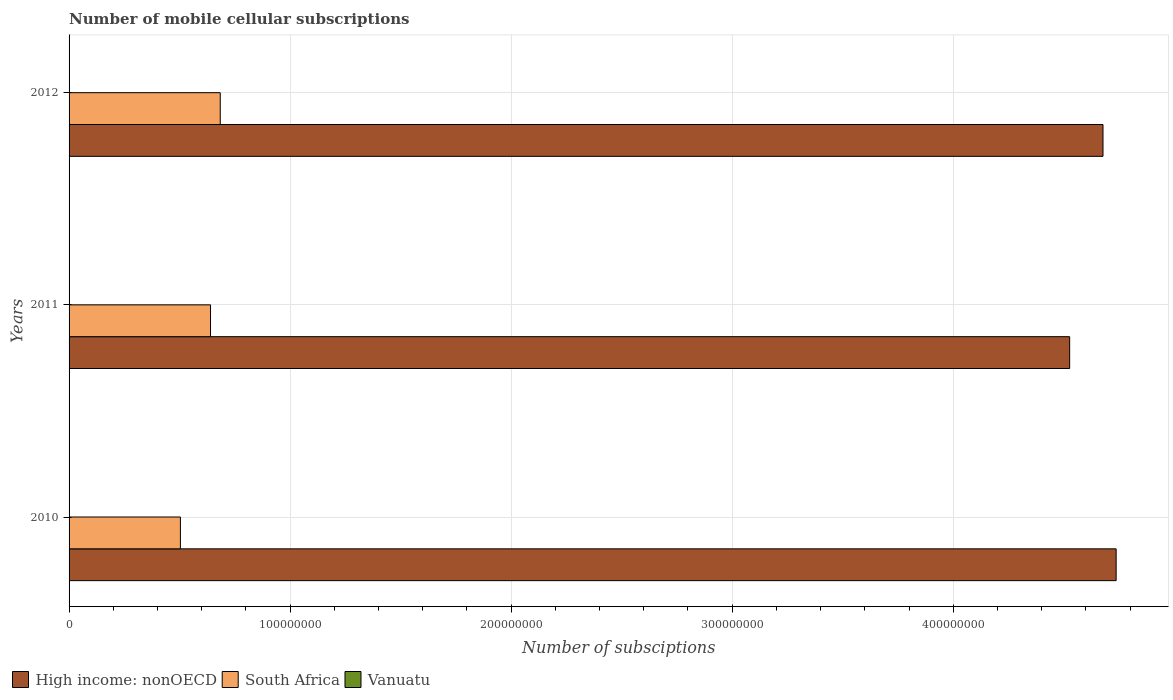How many different coloured bars are there?
Your answer should be very brief. 3. Are the number of bars per tick equal to the number of legend labels?
Ensure brevity in your answer.  Yes. How many bars are there on the 1st tick from the top?
Make the answer very short. 3. How many bars are there on the 1st tick from the bottom?
Your response must be concise. 3. What is the label of the 1st group of bars from the top?
Your response must be concise. 2012. In how many cases, is the number of bars for a given year not equal to the number of legend labels?
Offer a very short reply. 0. What is the number of mobile cellular subscriptions in Vanuatu in 2012?
Provide a short and direct response. 1.46e+05. Across all years, what is the maximum number of mobile cellular subscriptions in Vanuatu?
Make the answer very short. 1.70e+05. Across all years, what is the minimum number of mobile cellular subscriptions in South Africa?
Provide a short and direct response. 5.04e+07. What is the total number of mobile cellular subscriptions in South Africa in the graph?
Keep it short and to the point. 1.83e+08. What is the difference between the number of mobile cellular subscriptions in South Africa in 2010 and that in 2011?
Provide a succinct answer. -1.36e+07. What is the difference between the number of mobile cellular subscriptions in South Africa in 2010 and the number of mobile cellular subscriptions in High income: nonOECD in 2012?
Ensure brevity in your answer.  -4.17e+08. What is the average number of mobile cellular subscriptions in Vanuatu per year?
Your answer should be very brief. 1.51e+05. In the year 2010, what is the difference between the number of mobile cellular subscriptions in South Africa and number of mobile cellular subscriptions in Vanuatu?
Your answer should be compact. 5.02e+07. What is the ratio of the number of mobile cellular subscriptions in High income: nonOECD in 2010 to that in 2011?
Your answer should be compact. 1.05. Is the difference between the number of mobile cellular subscriptions in South Africa in 2010 and 2012 greater than the difference between the number of mobile cellular subscriptions in Vanuatu in 2010 and 2012?
Provide a short and direct response. No. What is the difference between the highest and the second highest number of mobile cellular subscriptions in South Africa?
Ensure brevity in your answer.  4.39e+06. What is the difference between the highest and the lowest number of mobile cellular subscriptions in South Africa?
Provide a succinct answer. 1.80e+07. Is the sum of the number of mobile cellular subscriptions in South Africa in 2010 and 2011 greater than the maximum number of mobile cellular subscriptions in Vanuatu across all years?
Make the answer very short. Yes. What does the 1st bar from the top in 2010 represents?
Your answer should be compact. Vanuatu. What does the 3rd bar from the bottom in 2011 represents?
Provide a succinct answer. Vanuatu. How many bars are there?
Keep it short and to the point. 9. How many years are there in the graph?
Ensure brevity in your answer.  3. Are the values on the major ticks of X-axis written in scientific E-notation?
Your response must be concise. No. Does the graph contain any zero values?
Ensure brevity in your answer.  No. Where does the legend appear in the graph?
Provide a succinct answer. Bottom left. What is the title of the graph?
Your answer should be very brief. Number of mobile cellular subscriptions. Does "St. Kitts and Nevis" appear as one of the legend labels in the graph?
Your answer should be compact. No. What is the label or title of the X-axis?
Make the answer very short. Number of subsciptions. What is the label or title of the Y-axis?
Your answer should be very brief. Years. What is the Number of subsciptions in High income: nonOECD in 2010?
Provide a succinct answer. 4.74e+08. What is the Number of subsciptions of South Africa in 2010?
Make the answer very short. 5.04e+07. What is the Number of subsciptions of Vanuatu in 2010?
Your response must be concise. 1.70e+05. What is the Number of subsciptions of High income: nonOECD in 2011?
Offer a very short reply. 4.53e+08. What is the Number of subsciptions in South Africa in 2011?
Your response must be concise. 6.40e+07. What is the Number of subsciptions of Vanuatu in 2011?
Your response must be concise. 1.37e+05. What is the Number of subsciptions in High income: nonOECD in 2012?
Make the answer very short. 4.68e+08. What is the Number of subsciptions of South Africa in 2012?
Keep it short and to the point. 6.84e+07. What is the Number of subsciptions of Vanuatu in 2012?
Ensure brevity in your answer.  1.46e+05. Across all years, what is the maximum Number of subsciptions in High income: nonOECD?
Offer a very short reply. 4.74e+08. Across all years, what is the maximum Number of subsciptions in South Africa?
Provide a succinct answer. 6.84e+07. Across all years, what is the maximum Number of subsciptions of Vanuatu?
Offer a very short reply. 1.70e+05. Across all years, what is the minimum Number of subsciptions of High income: nonOECD?
Provide a succinct answer. 4.53e+08. Across all years, what is the minimum Number of subsciptions in South Africa?
Your answer should be compact. 5.04e+07. Across all years, what is the minimum Number of subsciptions of Vanuatu?
Your response must be concise. 1.37e+05. What is the total Number of subsciptions of High income: nonOECD in the graph?
Make the answer very short. 1.39e+09. What is the total Number of subsciptions of South Africa in the graph?
Provide a short and direct response. 1.83e+08. What is the total Number of subsciptions in Vanuatu in the graph?
Make the answer very short. 4.53e+05. What is the difference between the Number of subsciptions of High income: nonOECD in 2010 and that in 2011?
Your answer should be compact. 2.10e+07. What is the difference between the Number of subsciptions in South Africa in 2010 and that in 2011?
Offer a very short reply. -1.36e+07. What is the difference between the Number of subsciptions of Vanuatu in 2010 and that in 2011?
Give a very brief answer. 3.30e+04. What is the difference between the Number of subsciptions of High income: nonOECD in 2010 and that in 2012?
Offer a terse response. 5.94e+06. What is the difference between the Number of subsciptions of South Africa in 2010 and that in 2012?
Keep it short and to the point. -1.80e+07. What is the difference between the Number of subsciptions in Vanuatu in 2010 and that in 2012?
Offer a very short reply. 2.39e+04. What is the difference between the Number of subsciptions of High income: nonOECD in 2011 and that in 2012?
Ensure brevity in your answer.  -1.51e+07. What is the difference between the Number of subsciptions in South Africa in 2011 and that in 2012?
Offer a terse response. -4.39e+06. What is the difference between the Number of subsciptions of Vanuatu in 2011 and that in 2012?
Offer a very short reply. -9128. What is the difference between the Number of subsciptions in High income: nonOECD in 2010 and the Number of subsciptions in South Africa in 2011?
Give a very brief answer. 4.10e+08. What is the difference between the Number of subsciptions of High income: nonOECD in 2010 and the Number of subsciptions of Vanuatu in 2011?
Your answer should be very brief. 4.74e+08. What is the difference between the Number of subsciptions in South Africa in 2010 and the Number of subsciptions in Vanuatu in 2011?
Offer a very short reply. 5.02e+07. What is the difference between the Number of subsciptions of High income: nonOECD in 2010 and the Number of subsciptions of South Africa in 2012?
Ensure brevity in your answer.  4.05e+08. What is the difference between the Number of subsciptions of High income: nonOECD in 2010 and the Number of subsciptions of Vanuatu in 2012?
Offer a very short reply. 4.74e+08. What is the difference between the Number of subsciptions of South Africa in 2010 and the Number of subsciptions of Vanuatu in 2012?
Keep it short and to the point. 5.02e+07. What is the difference between the Number of subsciptions in High income: nonOECD in 2011 and the Number of subsciptions in South Africa in 2012?
Provide a succinct answer. 3.84e+08. What is the difference between the Number of subsciptions of High income: nonOECD in 2011 and the Number of subsciptions of Vanuatu in 2012?
Ensure brevity in your answer.  4.53e+08. What is the difference between the Number of subsciptions in South Africa in 2011 and the Number of subsciptions in Vanuatu in 2012?
Make the answer very short. 6.39e+07. What is the average Number of subsciptions of High income: nonOECD per year?
Make the answer very short. 4.65e+08. What is the average Number of subsciptions in South Africa per year?
Provide a short and direct response. 6.09e+07. What is the average Number of subsciptions of Vanuatu per year?
Make the answer very short. 1.51e+05. In the year 2010, what is the difference between the Number of subsciptions in High income: nonOECD and Number of subsciptions in South Africa?
Keep it short and to the point. 4.23e+08. In the year 2010, what is the difference between the Number of subsciptions of High income: nonOECD and Number of subsciptions of Vanuatu?
Ensure brevity in your answer.  4.74e+08. In the year 2010, what is the difference between the Number of subsciptions of South Africa and Number of subsciptions of Vanuatu?
Give a very brief answer. 5.02e+07. In the year 2011, what is the difference between the Number of subsciptions of High income: nonOECD and Number of subsciptions of South Africa?
Offer a terse response. 3.89e+08. In the year 2011, what is the difference between the Number of subsciptions of High income: nonOECD and Number of subsciptions of Vanuatu?
Provide a succinct answer. 4.53e+08. In the year 2011, what is the difference between the Number of subsciptions of South Africa and Number of subsciptions of Vanuatu?
Your response must be concise. 6.39e+07. In the year 2012, what is the difference between the Number of subsciptions in High income: nonOECD and Number of subsciptions in South Africa?
Keep it short and to the point. 3.99e+08. In the year 2012, what is the difference between the Number of subsciptions in High income: nonOECD and Number of subsciptions in Vanuatu?
Your answer should be very brief. 4.68e+08. In the year 2012, what is the difference between the Number of subsciptions of South Africa and Number of subsciptions of Vanuatu?
Offer a terse response. 6.82e+07. What is the ratio of the Number of subsciptions of High income: nonOECD in 2010 to that in 2011?
Keep it short and to the point. 1.05. What is the ratio of the Number of subsciptions in South Africa in 2010 to that in 2011?
Your response must be concise. 0.79. What is the ratio of the Number of subsciptions of Vanuatu in 2010 to that in 2011?
Your response must be concise. 1.24. What is the ratio of the Number of subsciptions in High income: nonOECD in 2010 to that in 2012?
Provide a succinct answer. 1.01. What is the ratio of the Number of subsciptions of South Africa in 2010 to that in 2012?
Ensure brevity in your answer.  0.74. What is the ratio of the Number of subsciptions in Vanuatu in 2010 to that in 2012?
Provide a succinct answer. 1.16. What is the ratio of the Number of subsciptions of High income: nonOECD in 2011 to that in 2012?
Your answer should be very brief. 0.97. What is the ratio of the Number of subsciptions of South Africa in 2011 to that in 2012?
Your response must be concise. 0.94. What is the ratio of the Number of subsciptions in Vanuatu in 2011 to that in 2012?
Your answer should be very brief. 0.94. What is the difference between the highest and the second highest Number of subsciptions of High income: nonOECD?
Your answer should be very brief. 5.94e+06. What is the difference between the highest and the second highest Number of subsciptions in South Africa?
Provide a short and direct response. 4.39e+06. What is the difference between the highest and the second highest Number of subsciptions in Vanuatu?
Offer a very short reply. 2.39e+04. What is the difference between the highest and the lowest Number of subsciptions in High income: nonOECD?
Your answer should be very brief. 2.10e+07. What is the difference between the highest and the lowest Number of subsciptions of South Africa?
Ensure brevity in your answer.  1.80e+07. What is the difference between the highest and the lowest Number of subsciptions in Vanuatu?
Make the answer very short. 3.30e+04. 